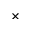Convert formula to latex. <formula><loc_0><loc_0><loc_500><loc_500>\times</formula> 